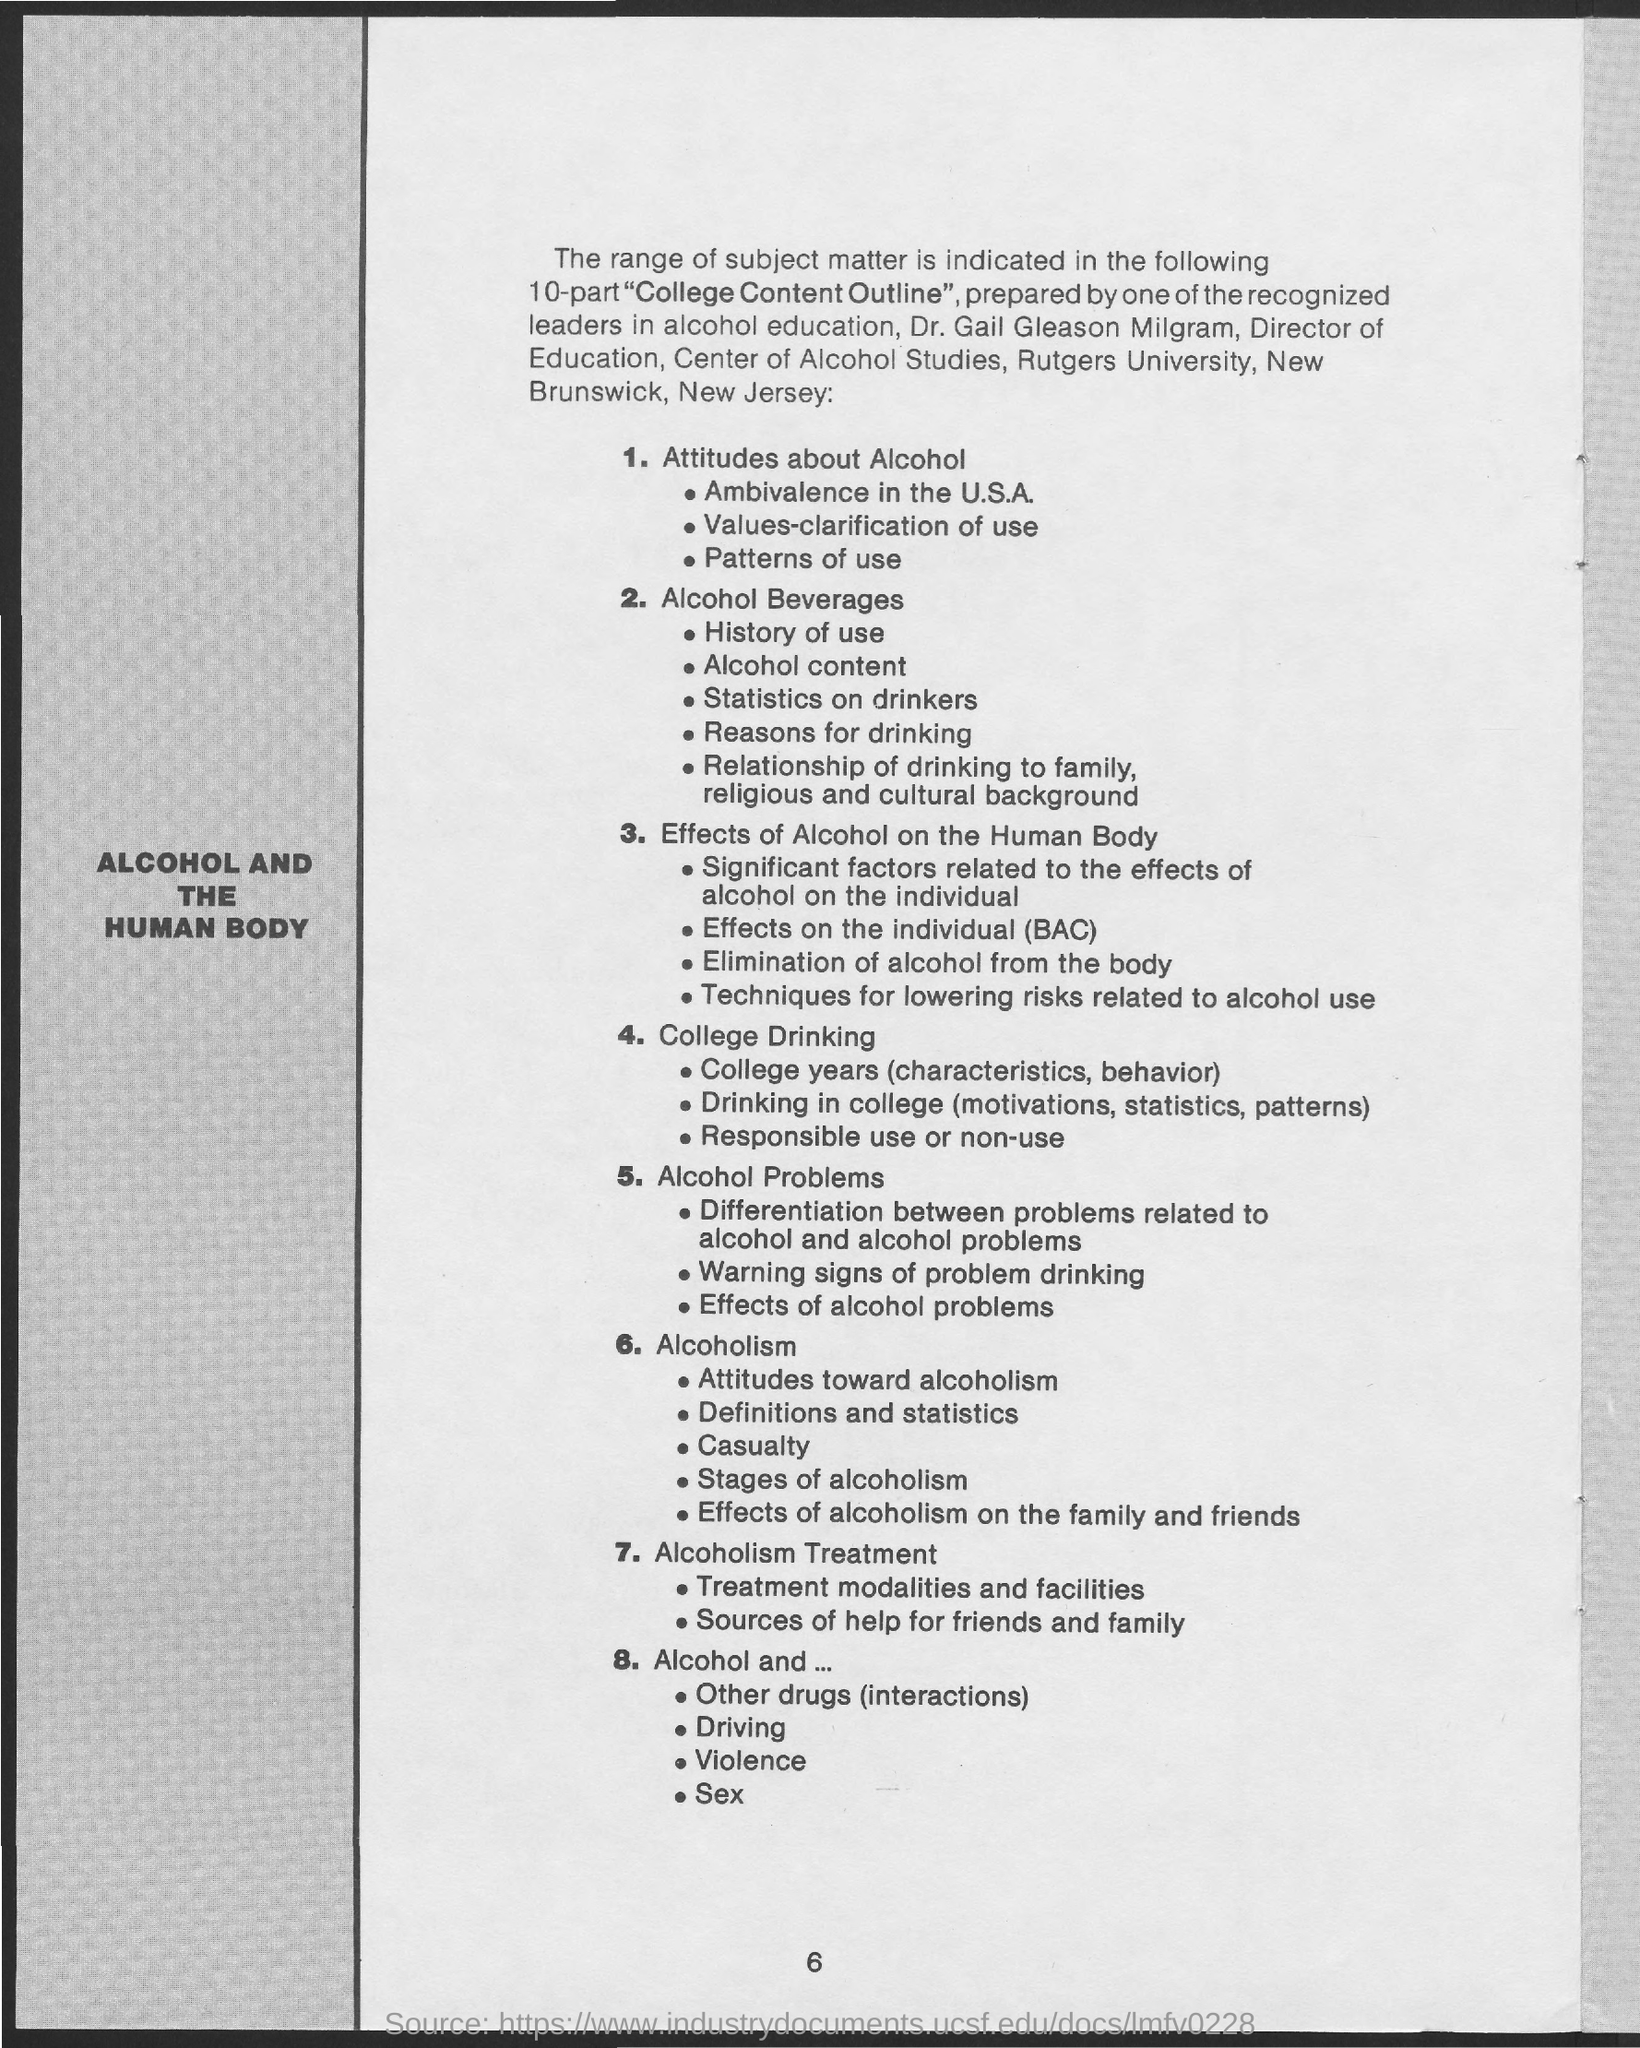Highlight a few significant elements in this photo. Dr. Gail Gleason Milgram is the Director of Education at the Center of Alcohol Studies. The page number mentioned in this document is 6.. 